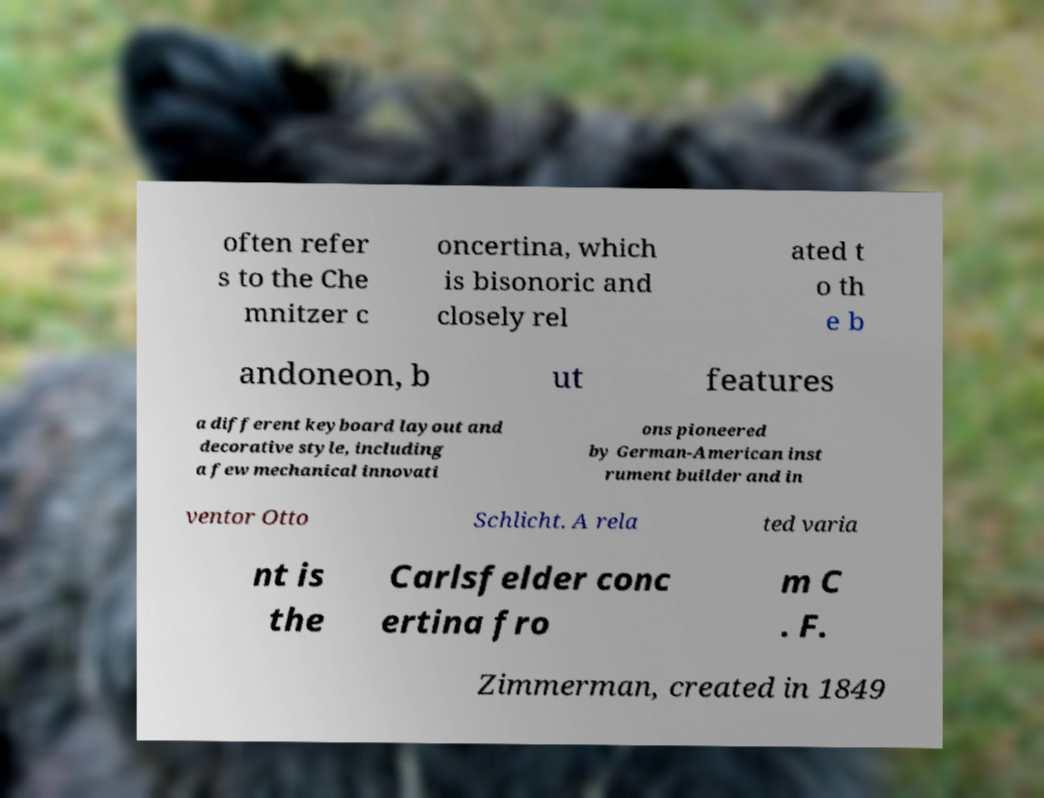What messages or text are displayed in this image? I need them in a readable, typed format. often refer s to the Che mnitzer c oncertina, which is bisonoric and closely rel ated t o th e b andoneon, b ut features a different keyboard layout and decorative style, including a few mechanical innovati ons pioneered by German-American inst rument builder and in ventor Otto Schlicht. A rela ted varia nt is the Carlsfelder conc ertina fro m C . F. Zimmerman, created in 1849 